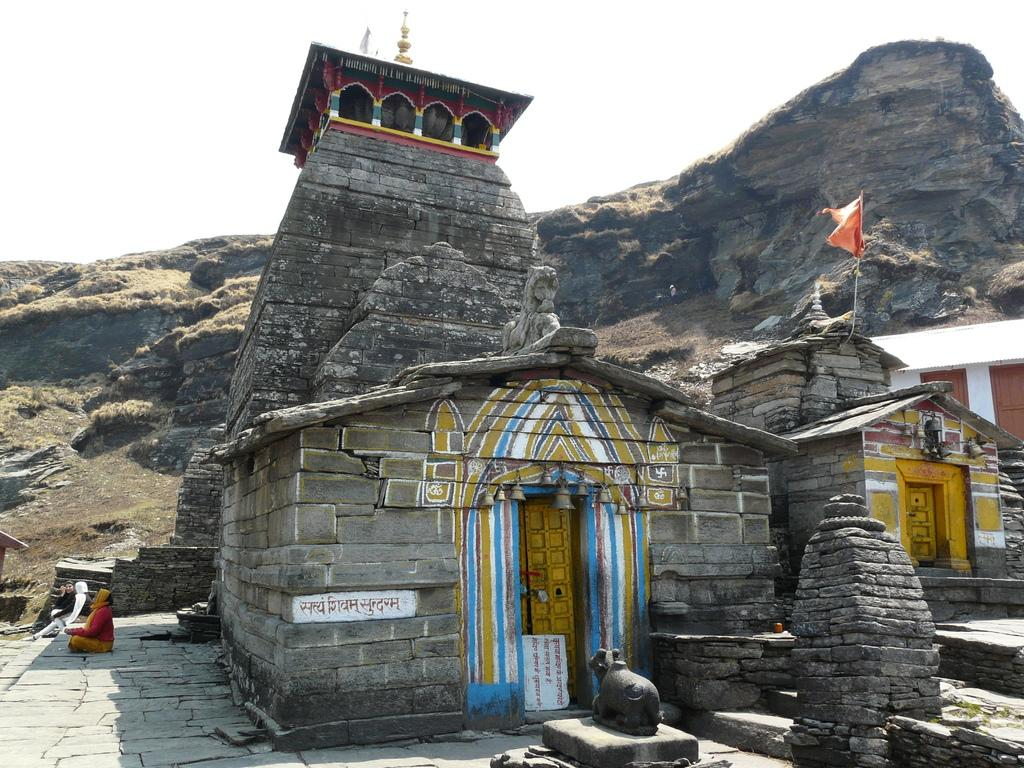What type of buildings can be seen in the image? There are temples in the image. What type of natural formation is present in the image? There are rock hills in the image. What is the surface on which the temples and rock hills are situated? The ground is visible in the image. What is the statue in the image representing? The statue in the image is not described in the facts, so we cannot determine what it represents. What is attached to a pole in the image? There is a flag in the image. Are there any living beings in the image? Yes, there are people in the image. What is visible above the temples, rock hills, and people? The sky is visible in the image. What type of snow can be seen falling on the temples in the image? There is no mention of snow in the image, so we cannot determine if any snow is present. What subject is the teacher teaching to the friend in the image? There is no mention of teaching or friends in the image, so we cannot determine if any teaching or friends are present. 